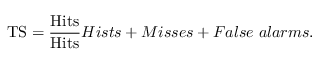Convert formula to latex. <formula><loc_0><loc_0><loc_500><loc_500>T S = \frac { H i t s } { H i t s } { H i s t s + M i s s e s + F a l s e \ a l a r m s } .</formula> 